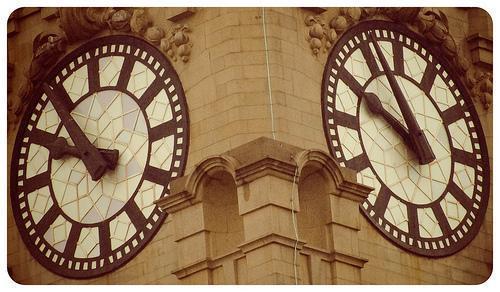How many clock faces are visible?
Give a very brief answer. 2. How many clock arms are visible?
Give a very brief answer. 4. 